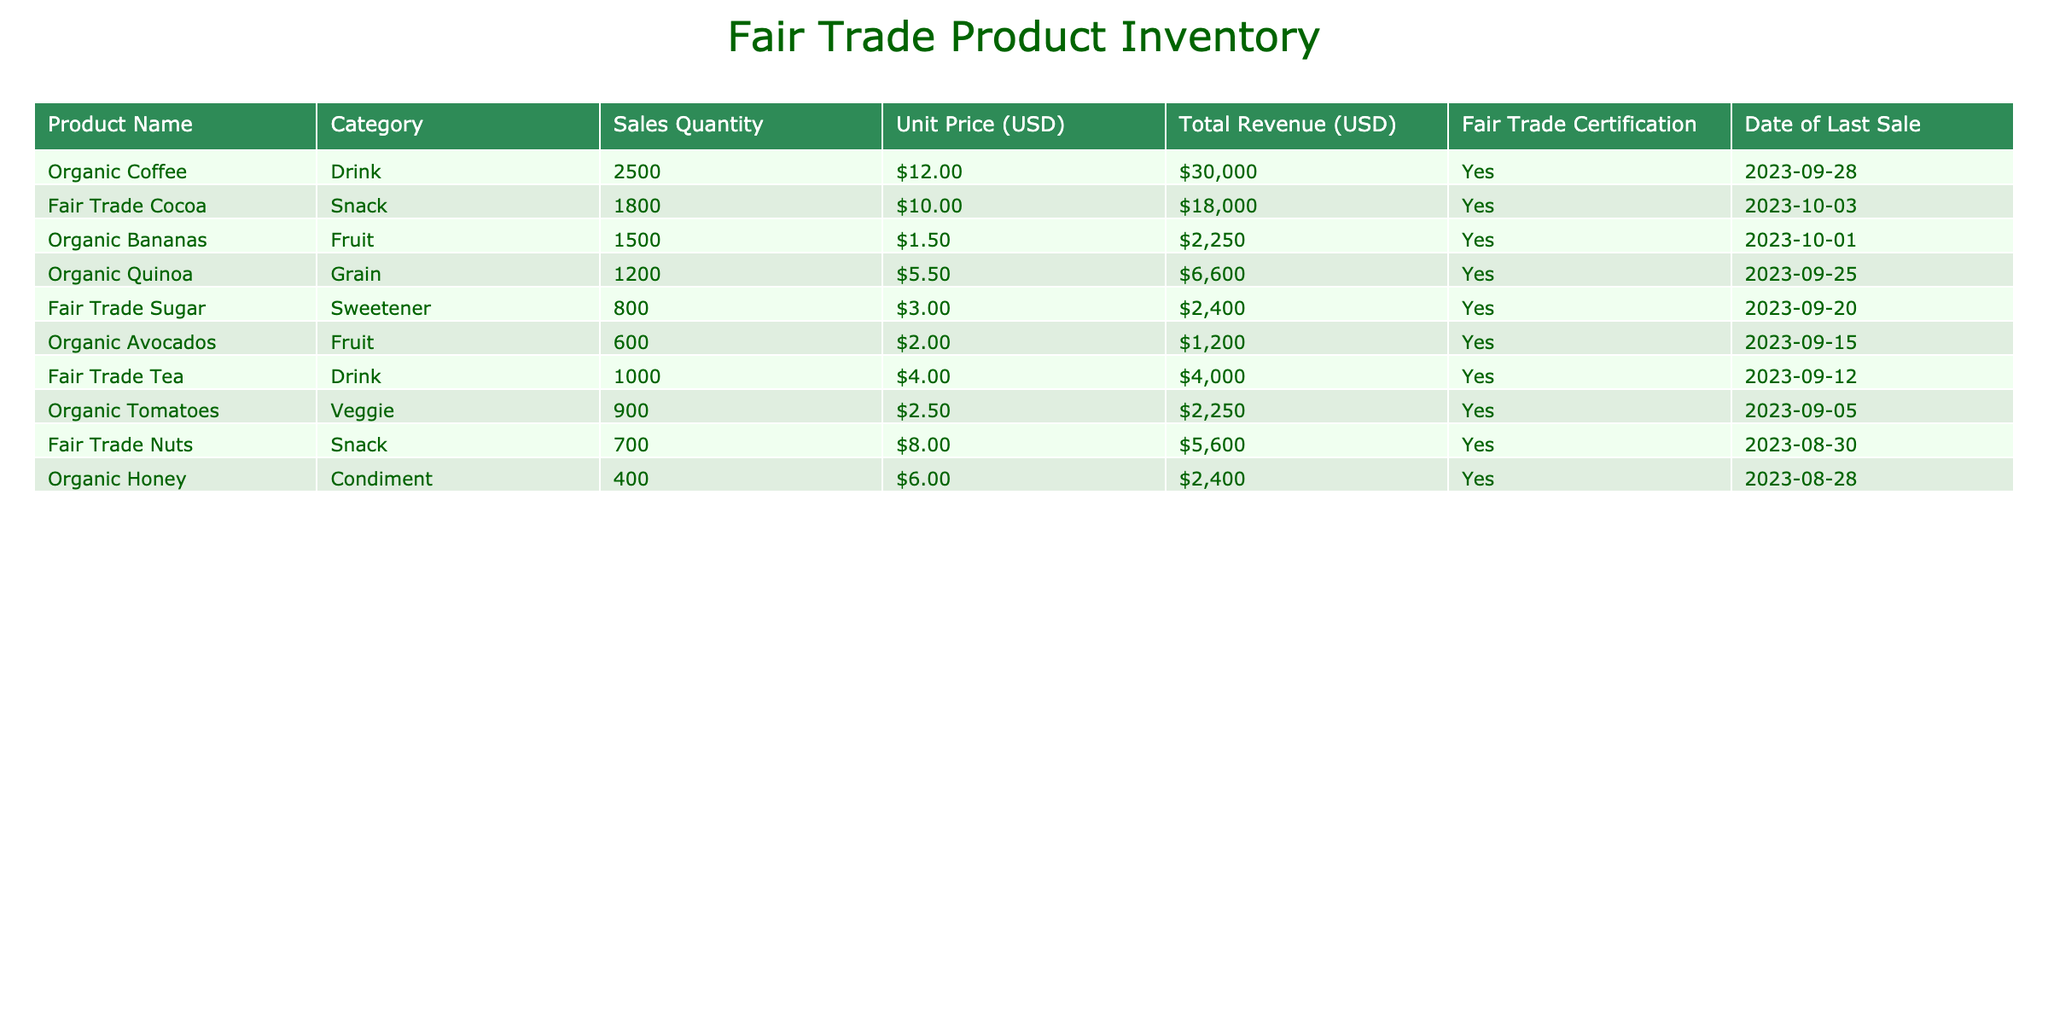What is the total revenue generated from organic coffee sales? The table shows that the total revenue for organic coffee is listed under the "Total Revenue (USD)" column. The specific value for organic coffee is $30,000.
Answer: $30,000 How many units of fair trade cocoa were sold? To find the quantity sold, we look under the "Sales Quantity" column for fair trade cocoa, which shows the value as 1,800 units.
Answer: 1,800 What is the average unit price of the fair trade products listed? To find the average, we need to add the unit prices of all products: 12.00 + 10.00 + 1.50 + 5.50 + 3.00 + 2.00 + 4.00 + 2.50 + 8.00 + 6.00 = 52.50. There are 10 products, so the average unit price is 52.50 / 10 = 5.25.
Answer: 5.25 Is the total revenue from organic bananas greater than the total revenue from organic quinoa? The total revenue for organic bananas is $2,250 and for organic quinoa it is $6,600. Since $2,250 is less than $6,600, the statement is false.
Answer: No What is the total revenue from fruit category sales? To calculate the total revenue from fruits, add the total revenues of organic bananas ($2,250) and organic avocados ($1,200), which gives us $2,250 + $1,200 = $3,450 as the total revenue from the fruit category.
Answer: $3,450 Was the last sale date for fair trade sugar before the last sale date for organic avocados? The last sale date for fair trade sugar is 2023-09-20 and for organic avocados, it is 2023-09-15. Since September 20 is later than September 15, the statement is false.
Answer: No What percentage of the total revenue in the table is generated by organic coffee sales? The total revenue from all products is $30,000 + $18,000 + $2,250 + $6,600 + $2,400 + $1,200 + $4,000 + $2,250 + $5,600 + $2,400 = $70,000. To find the percentage contributed by organic coffee, we calculate (30,000 / 70,000) * 100 = 42.86%.
Answer: 42.86% How many total units were sold for all fair trade snack products combined? The total units sold for fair trade snacks are represented by fair trade cocoa (1,800) and fair trade nuts (700). Adding them gives 1,800 + 700 = 2,500 units sold for all fair trade snacks.
Answer: 2,500 Which product has the highest total revenue and what is the revenue? Looking at the "Total Revenue (USD)" column, organic coffee has the highest revenue of $30,000.
Answer: Organic Coffee, $30,000 